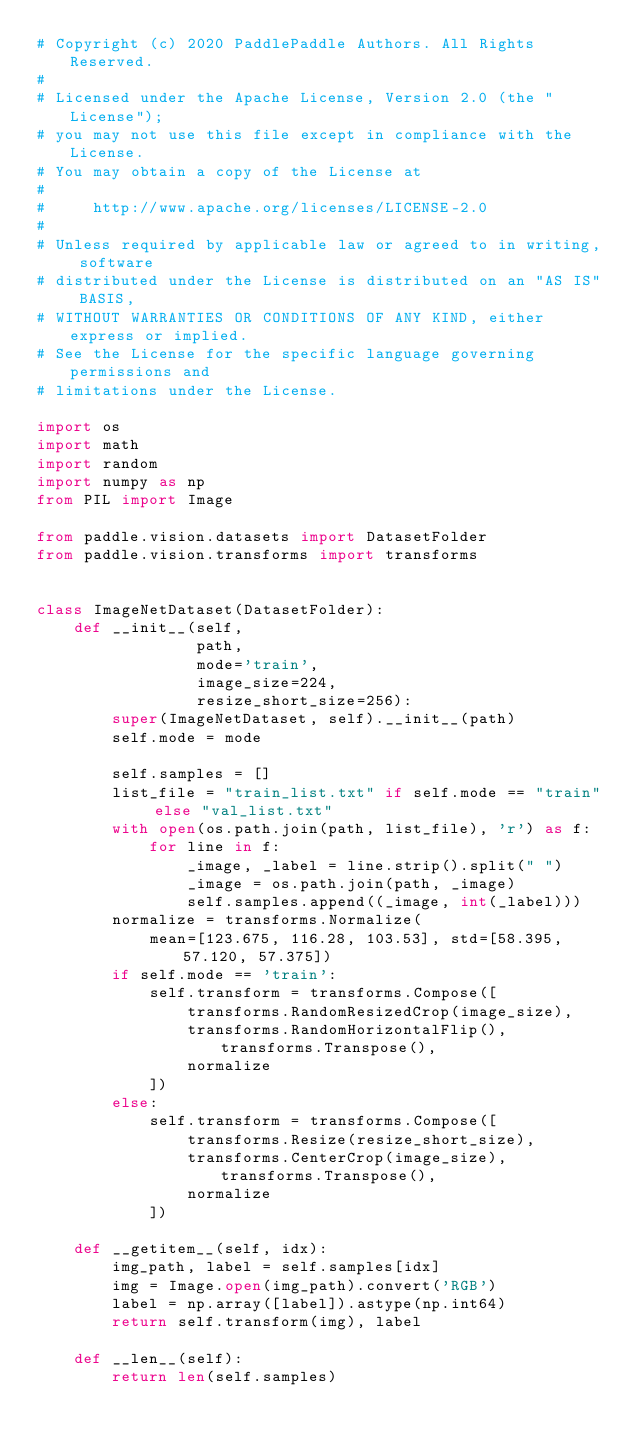Convert code to text. <code><loc_0><loc_0><loc_500><loc_500><_Python_># Copyright (c) 2020 PaddlePaddle Authors. All Rights Reserved.
#
# Licensed under the Apache License, Version 2.0 (the "License");
# you may not use this file except in compliance with the License.
# You may obtain a copy of the License at
#
#     http://www.apache.org/licenses/LICENSE-2.0
#
# Unless required by applicable law or agreed to in writing, software
# distributed under the License is distributed on an "AS IS" BASIS,
# WITHOUT WARRANTIES OR CONDITIONS OF ANY KIND, either express or implied.
# See the License for the specific language governing permissions and
# limitations under the License.

import os
import math
import random
import numpy as np
from PIL import Image

from paddle.vision.datasets import DatasetFolder
from paddle.vision.transforms import transforms


class ImageNetDataset(DatasetFolder):
    def __init__(self,
                 path,
                 mode='train',
                 image_size=224,
                 resize_short_size=256):
        super(ImageNetDataset, self).__init__(path)
        self.mode = mode

        self.samples = []
        list_file = "train_list.txt" if self.mode == "train" else "val_list.txt"
        with open(os.path.join(path, list_file), 'r') as f:
            for line in f:
                _image, _label = line.strip().split(" ")
                _image = os.path.join(path, _image)
                self.samples.append((_image, int(_label)))
        normalize = transforms.Normalize(
            mean=[123.675, 116.28, 103.53], std=[58.395, 57.120, 57.375])
        if self.mode == 'train':
            self.transform = transforms.Compose([
                transforms.RandomResizedCrop(image_size),
                transforms.RandomHorizontalFlip(), transforms.Transpose(),
                normalize
            ])
        else:
            self.transform = transforms.Compose([
                transforms.Resize(resize_short_size),
                transforms.CenterCrop(image_size), transforms.Transpose(),
                normalize
            ])

    def __getitem__(self, idx):
        img_path, label = self.samples[idx]
        img = Image.open(img_path).convert('RGB')
        label = np.array([label]).astype(np.int64)
        return self.transform(img), label

    def __len__(self):
        return len(self.samples)
</code> 